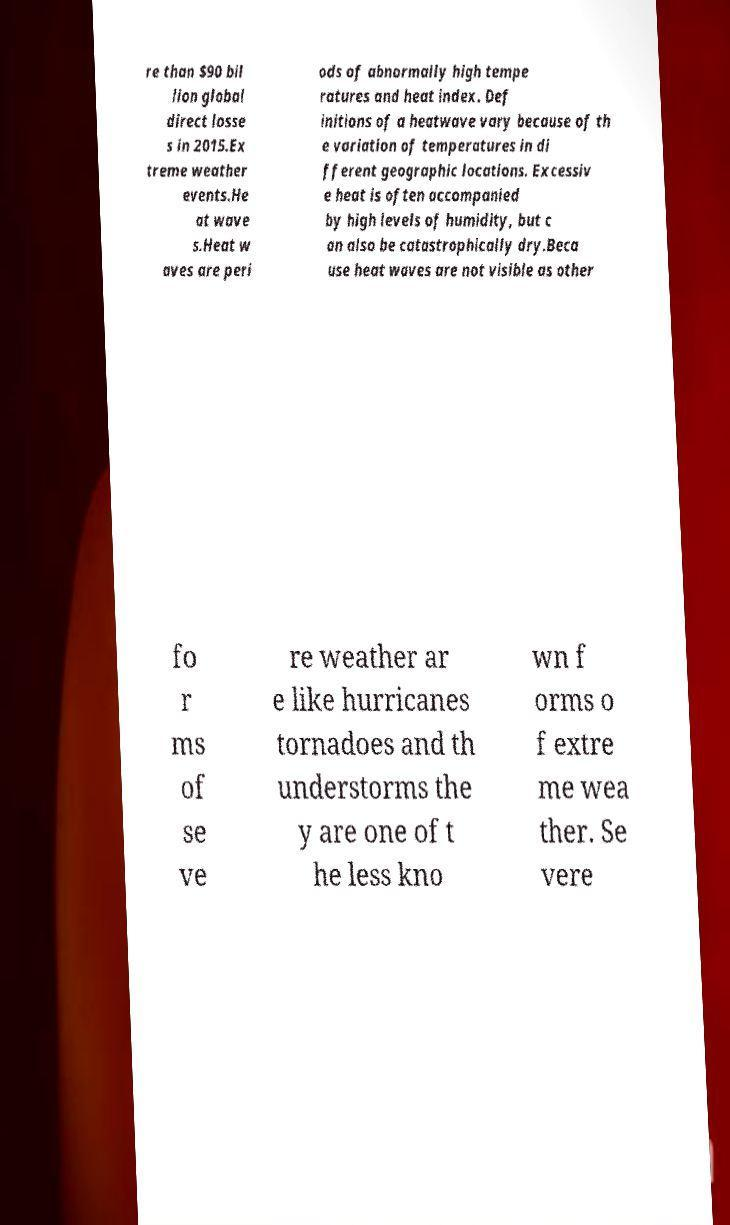Could you extract and type out the text from this image? re than $90 bil lion global direct losse s in 2015.Ex treme weather events.He at wave s.Heat w aves are peri ods of abnormally high tempe ratures and heat index. Def initions of a heatwave vary because of th e variation of temperatures in di fferent geographic locations. Excessiv e heat is often accompanied by high levels of humidity, but c an also be catastrophically dry.Beca use heat waves are not visible as other fo r ms of se ve re weather ar e like hurricanes tornadoes and th understorms the y are one of t he less kno wn f orms o f extre me wea ther. Se vere 